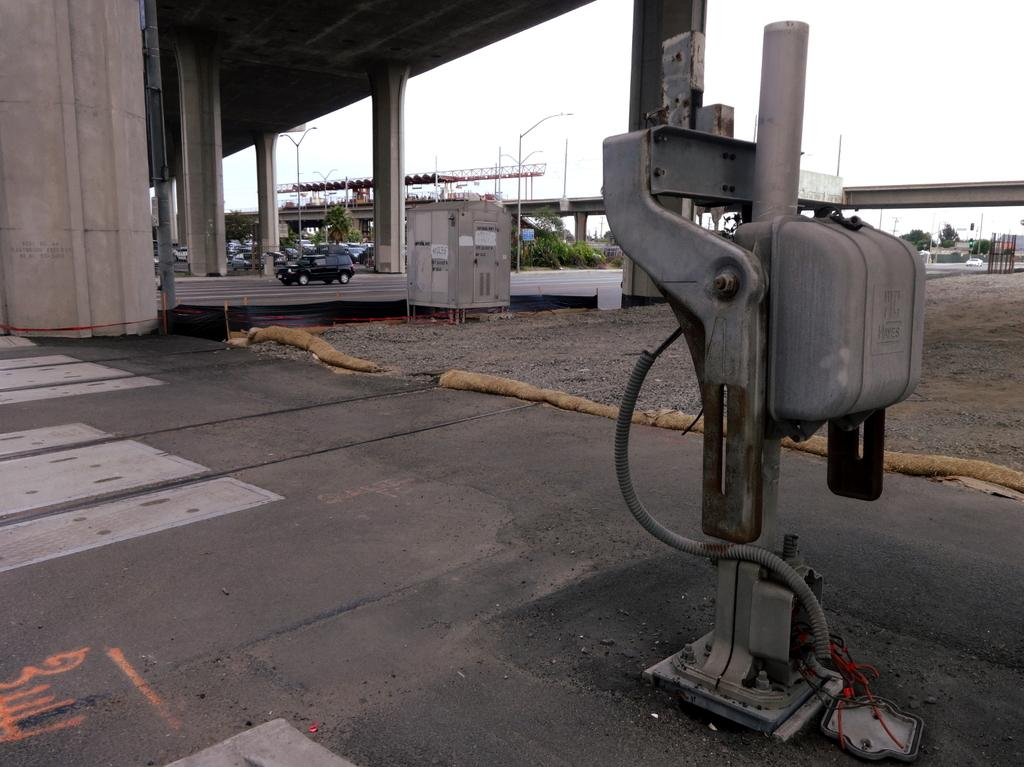What types of objects can be seen on the road in the image? There are machines and vehicles on the road in the image. What other features can be seen in the image? There are street lights and trees in the background of the image. Is there any indication of a larger structure in the background? Yes, there is a bridge in the background of the image. What type of boat can be seen in the aftermath of the storm in the image? There is no boat or storm present in the image; it features machines, vehicles, street lights, trees, and a bridge. 